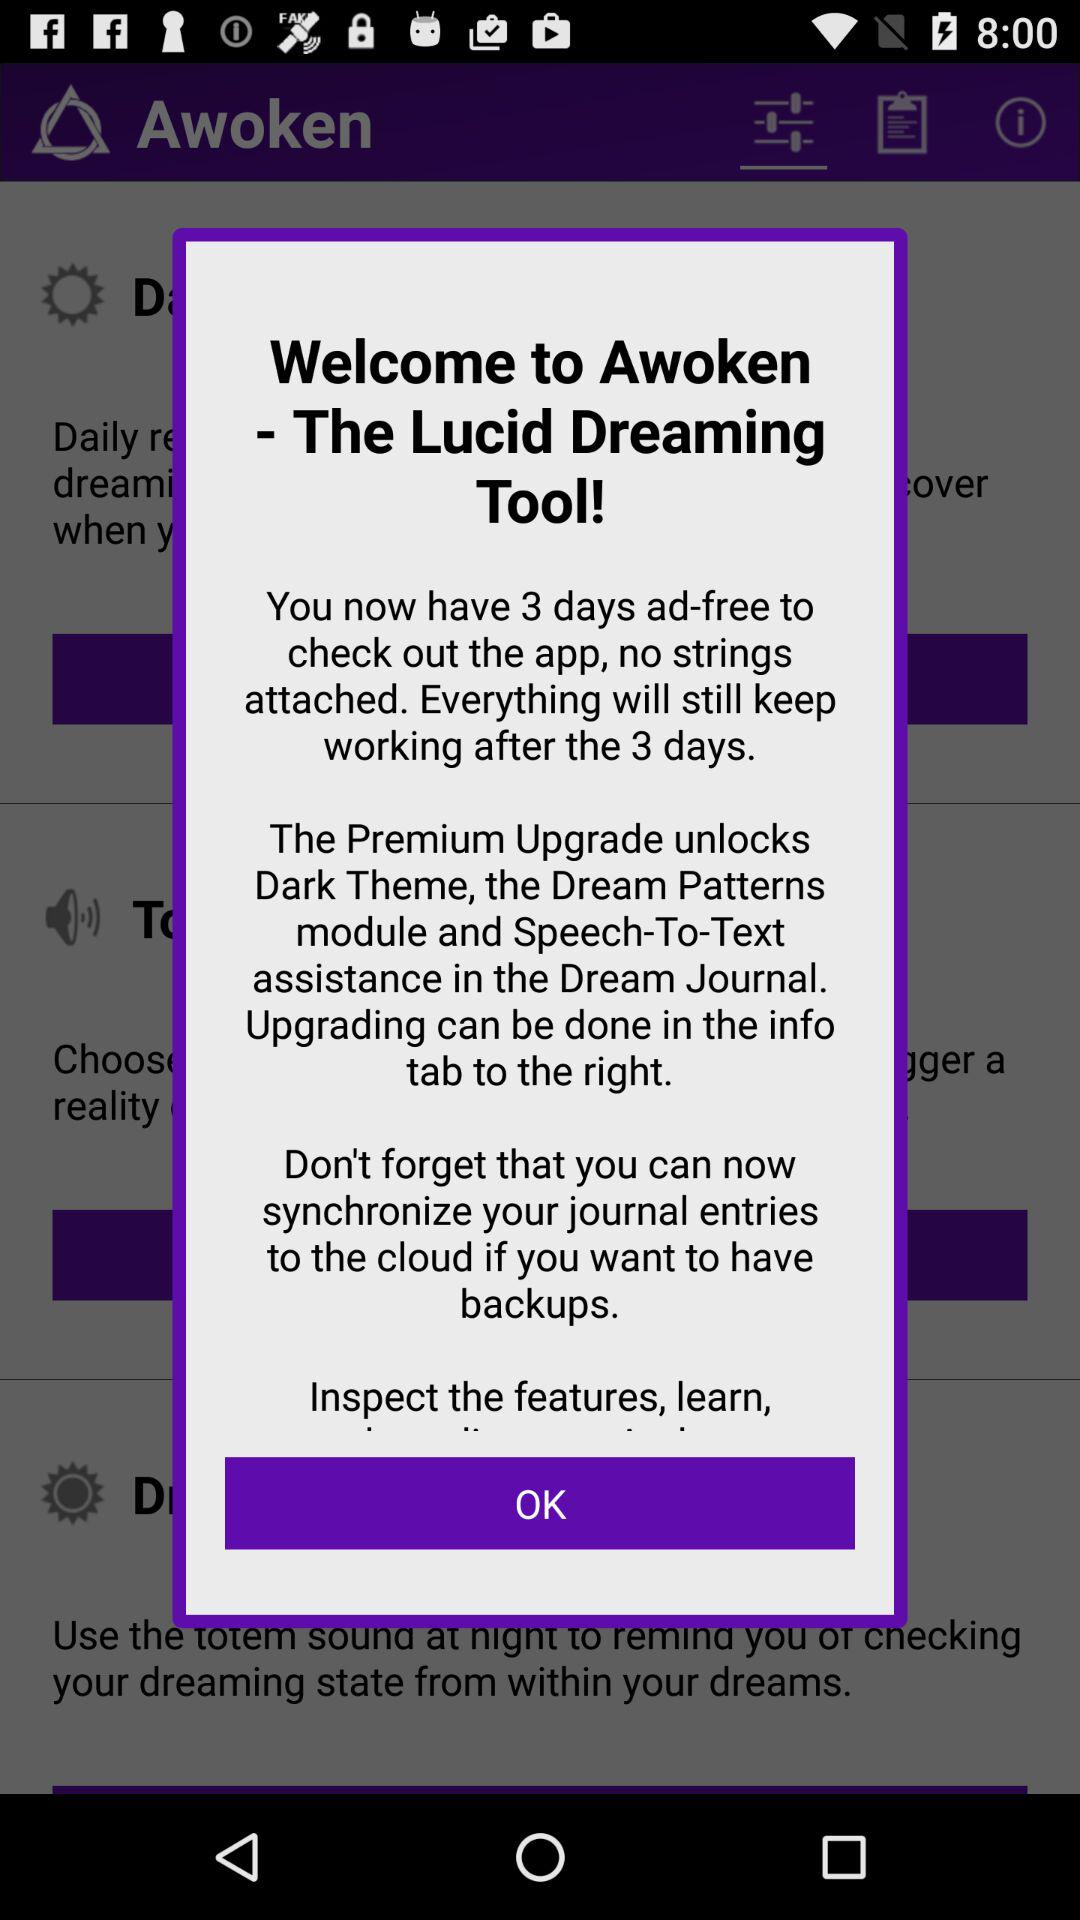How many ad-free days are there to check out the application? There are 3 ad-free days to check out the application. 